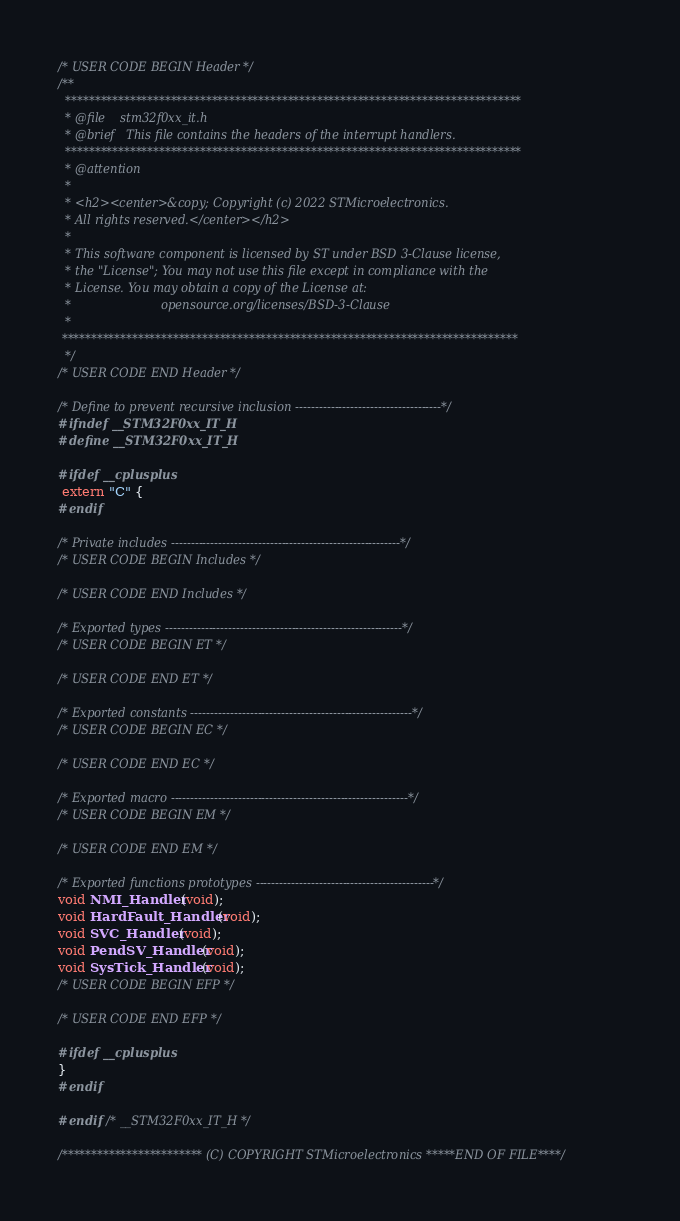Convert code to text. <code><loc_0><loc_0><loc_500><loc_500><_C_>/* USER CODE BEGIN Header */
/**
  ******************************************************************************
  * @file    stm32f0xx_it.h
  * @brief   This file contains the headers of the interrupt handlers.
  ******************************************************************************
  * @attention
  *
  * <h2><center>&copy; Copyright (c) 2022 STMicroelectronics.
  * All rights reserved.</center></h2>
  *
  * This software component is licensed by ST under BSD 3-Clause license,
  * the "License"; You may not use this file except in compliance with the
  * License. You may obtain a copy of the License at:
  *                        opensource.org/licenses/BSD-3-Clause
  *
 ******************************************************************************
  */
/* USER CODE END Header */

/* Define to prevent recursive inclusion -------------------------------------*/
#ifndef __STM32F0xx_IT_H
#define __STM32F0xx_IT_H

#ifdef __cplusplus
 extern "C" {
#endif 

/* Private includes ----------------------------------------------------------*/
/* USER CODE BEGIN Includes */

/* USER CODE END Includes */

/* Exported types ------------------------------------------------------------*/
/* USER CODE BEGIN ET */

/* USER CODE END ET */

/* Exported constants --------------------------------------------------------*/
/* USER CODE BEGIN EC */

/* USER CODE END EC */

/* Exported macro ------------------------------------------------------------*/
/* USER CODE BEGIN EM */

/* USER CODE END EM */

/* Exported functions prototypes ---------------------------------------------*/
void NMI_Handler(void);
void HardFault_Handler(void);
void SVC_Handler(void);
void PendSV_Handler(void);
void SysTick_Handler(void);
/* USER CODE BEGIN EFP */

/* USER CODE END EFP */

#ifdef __cplusplus
}
#endif

#endif /* __STM32F0xx_IT_H */

/************************ (C) COPYRIGHT STMicroelectronics *****END OF FILE****/
</code> 